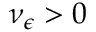<formula> <loc_0><loc_0><loc_500><loc_500>\nu _ { \epsilon } > 0</formula> 